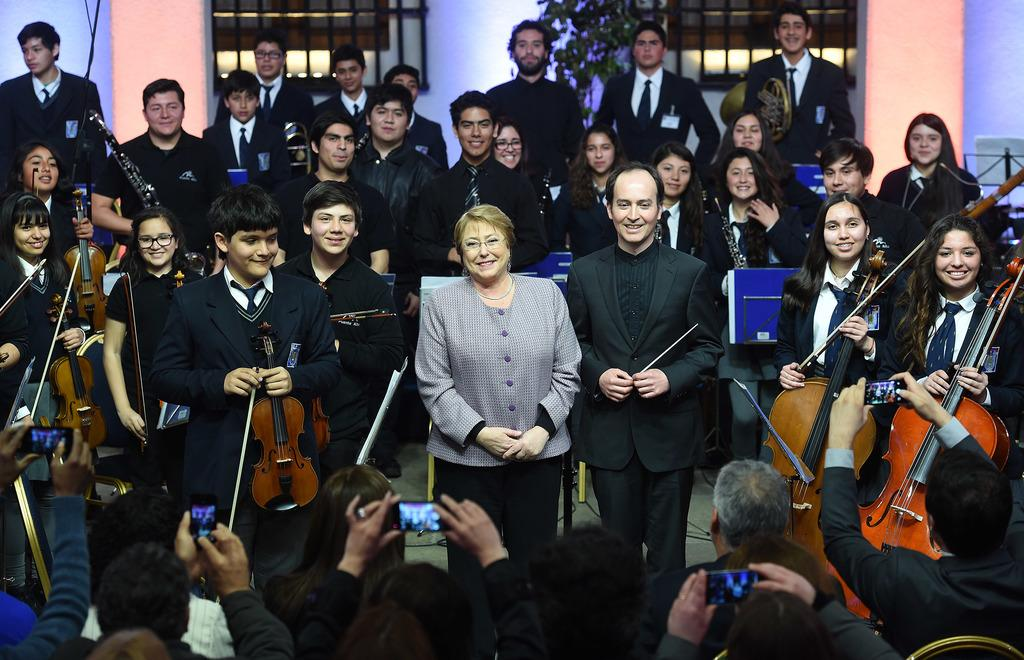What are the people in the image doing? People are standing and playing musical instruments. What objects are the people holding in the image? The people are holding phones. What can be seen in the background of the image? There is a plant, a window, and a wall in the background. What type of substance is the rat chewing on in the image? There is no rat present in the image, so it is not possible to answer that question. 